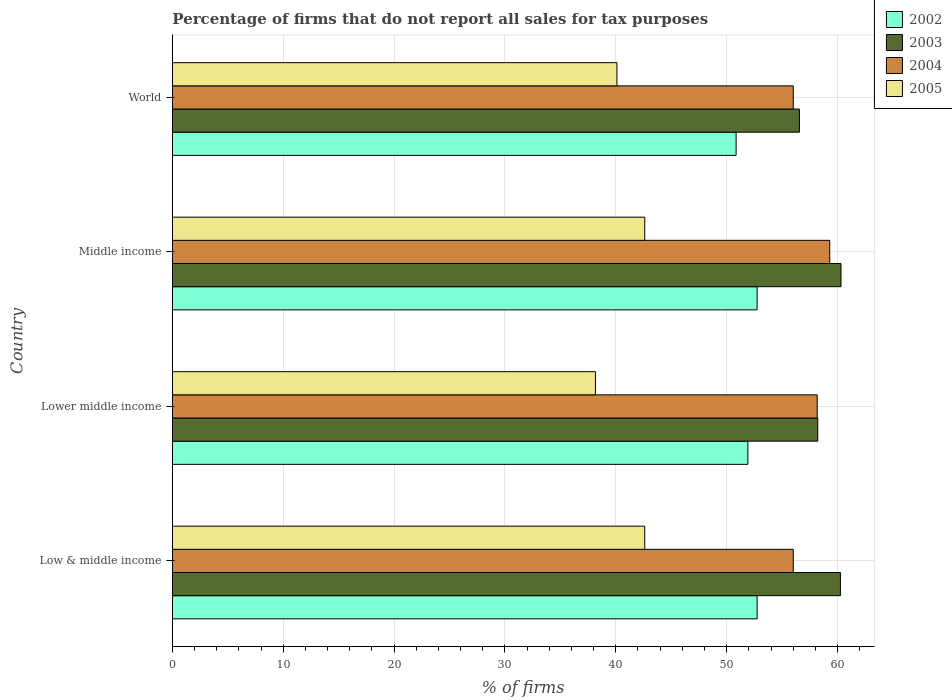Are the number of bars per tick equal to the number of legend labels?
Your answer should be compact. Yes. How many bars are there on the 3rd tick from the top?
Provide a succinct answer. 4. How many bars are there on the 1st tick from the bottom?
Your response must be concise. 4. What is the label of the 2nd group of bars from the top?
Ensure brevity in your answer.  Middle income. What is the percentage of firms that do not report all sales for tax purposes in 2002 in Low & middle income?
Provide a succinct answer. 52.75. Across all countries, what is the maximum percentage of firms that do not report all sales for tax purposes in 2003?
Provide a short and direct response. 60.31. Across all countries, what is the minimum percentage of firms that do not report all sales for tax purposes in 2005?
Offer a very short reply. 38.16. In which country was the percentage of firms that do not report all sales for tax purposes in 2003 maximum?
Make the answer very short. Middle income. What is the total percentage of firms that do not report all sales for tax purposes in 2004 in the graph?
Offer a terse response. 229.47. What is the difference between the percentage of firms that do not report all sales for tax purposes in 2003 in Lower middle income and that in World?
Keep it short and to the point. 1.66. What is the difference between the percentage of firms that do not report all sales for tax purposes in 2003 in Lower middle income and the percentage of firms that do not report all sales for tax purposes in 2004 in World?
Ensure brevity in your answer.  2.21. What is the average percentage of firms that do not report all sales for tax purposes in 2004 per country?
Give a very brief answer. 57.37. What is the difference between the percentage of firms that do not report all sales for tax purposes in 2005 and percentage of firms that do not report all sales for tax purposes in 2002 in Middle income?
Give a very brief answer. -10.13. In how many countries, is the percentage of firms that do not report all sales for tax purposes in 2005 greater than 2 %?
Offer a very short reply. 4. What is the ratio of the percentage of firms that do not report all sales for tax purposes in 2003 in Low & middle income to that in Middle income?
Offer a very short reply. 1. Is the percentage of firms that do not report all sales for tax purposes in 2005 in Low & middle income less than that in World?
Offer a very short reply. No. What is the difference between the highest and the lowest percentage of firms that do not report all sales for tax purposes in 2004?
Offer a very short reply. 3.29. What does the 1st bar from the top in Low & middle income represents?
Offer a very short reply. 2005. What is the difference between two consecutive major ticks on the X-axis?
Your answer should be very brief. 10. Does the graph contain any zero values?
Offer a very short reply. No. Does the graph contain grids?
Offer a terse response. Yes. Where does the legend appear in the graph?
Make the answer very short. Top right. How many legend labels are there?
Your response must be concise. 4. How are the legend labels stacked?
Provide a succinct answer. Vertical. What is the title of the graph?
Give a very brief answer. Percentage of firms that do not report all sales for tax purposes. What is the label or title of the X-axis?
Offer a very short reply. % of firms. What is the % of firms of 2002 in Low & middle income?
Offer a very short reply. 52.75. What is the % of firms in 2003 in Low & middle income?
Keep it short and to the point. 60.26. What is the % of firms of 2004 in Low & middle income?
Your response must be concise. 56.01. What is the % of firms of 2005 in Low & middle income?
Provide a short and direct response. 42.61. What is the % of firms in 2002 in Lower middle income?
Offer a very short reply. 51.91. What is the % of firms of 2003 in Lower middle income?
Your answer should be very brief. 58.22. What is the % of firms in 2004 in Lower middle income?
Ensure brevity in your answer.  58.16. What is the % of firms of 2005 in Lower middle income?
Provide a short and direct response. 38.16. What is the % of firms of 2002 in Middle income?
Provide a short and direct response. 52.75. What is the % of firms in 2003 in Middle income?
Your answer should be very brief. 60.31. What is the % of firms in 2004 in Middle income?
Offer a terse response. 59.3. What is the % of firms of 2005 in Middle income?
Provide a succinct answer. 42.61. What is the % of firms in 2002 in World?
Give a very brief answer. 50.85. What is the % of firms of 2003 in World?
Give a very brief answer. 56.56. What is the % of firms of 2004 in World?
Offer a very short reply. 56.01. What is the % of firms of 2005 in World?
Offer a very short reply. 40.1. Across all countries, what is the maximum % of firms of 2002?
Your answer should be very brief. 52.75. Across all countries, what is the maximum % of firms in 2003?
Your answer should be very brief. 60.31. Across all countries, what is the maximum % of firms of 2004?
Offer a terse response. 59.3. Across all countries, what is the maximum % of firms of 2005?
Give a very brief answer. 42.61. Across all countries, what is the minimum % of firms of 2002?
Provide a short and direct response. 50.85. Across all countries, what is the minimum % of firms in 2003?
Give a very brief answer. 56.56. Across all countries, what is the minimum % of firms in 2004?
Provide a short and direct response. 56.01. Across all countries, what is the minimum % of firms of 2005?
Your answer should be compact. 38.16. What is the total % of firms of 2002 in the graph?
Provide a succinct answer. 208.25. What is the total % of firms in 2003 in the graph?
Offer a very short reply. 235.35. What is the total % of firms in 2004 in the graph?
Keep it short and to the point. 229.47. What is the total % of firms of 2005 in the graph?
Keep it short and to the point. 163.48. What is the difference between the % of firms in 2002 in Low & middle income and that in Lower middle income?
Give a very brief answer. 0.84. What is the difference between the % of firms in 2003 in Low & middle income and that in Lower middle income?
Your response must be concise. 2.04. What is the difference between the % of firms in 2004 in Low & middle income and that in Lower middle income?
Offer a very short reply. -2.16. What is the difference between the % of firms in 2005 in Low & middle income and that in Lower middle income?
Offer a very short reply. 4.45. What is the difference between the % of firms in 2003 in Low & middle income and that in Middle income?
Your answer should be compact. -0.05. What is the difference between the % of firms in 2004 in Low & middle income and that in Middle income?
Your answer should be very brief. -3.29. What is the difference between the % of firms of 2005 in Low & middle income and that in Middle income?
Provide a short and direct response. 0. What is the difference between the % of firms in 2002 in Low & middle income and that in World?
Keep it short and to the point. 1.89. What is the difference between the % of firms of 2003 in Low & middle income and that in World?
Give a very brief answer. 3.7. What is the difference between the % of firms of 2005 in Low & middle income and that in World?
Give a very brief answer. 2.51. What is the difference between the % of firms in 2002 in Lower middle income and that in Middle income?
Your response must be concise. -0.84. What is the difference between the % of firms of 2003 in Lower middle income and that in Middle income?
Provide a short and direct response. -2.09. What is the difference between the % of firms in 2004 in Lower middle income and that in Middle income?
Keep it short and to the point. -1.13. What is the difference between the % of firms of 2005 in Lower middle income and that in Middle income?
Your answer should be very brief. -4.45. What is the difference between the % of firms in 2002 in Lower middle income and that in World?
Your response must be concise. 1.06. What is the difference between the % of firms of 2003 in Lower middle income and that in World?
Offer a very short reply. 1.66. What is the difference between the % of firms of 2004 in Lower middle income and that in World?
Give a very brief answer. 2.16. What is the difference between the % of firms of 2005 in Lower middle income and that in World?
Offer a very short reply. -1.94. What is the difference between the % of firms in 2002 in Middle income and that in World?
Ensure brevity in your answer.  1.89. What is the difference between the % of firms of 2003 in Middle income and that in World?
Ensure brevity in your answer.  3.75. What is the difference between the % of firms of 2004 in Middle income and that in World?
Your response must be concise. 3.29. What is the difference between the % of firms in 2005 in Middle income and that in World?
Make the answer very short. 2.51. What is the difference between the % of firms in 2002 in Low & middle income and the % of firms in 2003 in Lower middle income?
Offer a very short reply. -5.47. What is the difference between the % of firms of 2002 in Low & middle income and the % of firms of 2004 in Lower middle income?
Offer a very short reply. -5.42. What is the difference between the % of firms in 2002 in Low & middle income and the % of firms in 2005 in Lower middle income?
Make the answer very short. 14.58. What is the difference between the % of firms in 2003 in Low & middle income and the % of firms in 2004 in Lower middle income?
Provide a short and direct response. 2.1. What is the difference between the % of firms in 2003 in Low & middle income and the % of firms in 2005 in Lower middle income?
Ensure brevity in your answer.  22.1. What is the difference between the % of firms in 2004 in Low & middle income and the % of firms in 2005 in Lower middle income?
Make the answer very short. 17.84. What is the difference between the % of firms of 2002 in Low & middle income and the % of firms of 2003 in Middle income?
Give a very brief answer. -7.57. What is the difference between the % of firms in 2002 in Low & middle income and the % of firms in 2004 in Middle income?
Keep it short and to the point. -6.55. What is the difference between the % of firms of 2002 in Low & middle income and the % of firms of 2005 in Middle income?
Ensure brevity in your answer.  10.13. What is the difference between the % of firms in 2003 in Low & middle income and the % of firms in 2004 in Middle income?
Provide a short and direct response. 0.96. What is the difference between the % of firms of 2003 in Low & middle income and the % of firms of 2005 in Middle income?
Your response must be concise. 17.65. What is the difference between the % of firms of 2004 in Low & middle income and the % of firms of 2005 in Middle income?
Make the answer very short. 13.39. What is the difference between the % of firms in 2002 in Low & middle income and the % of firms in 2003 in World?
Make the answer very short. -3.81. What is the difference between the % of firms in 2002 in Low & middle income and the % of firms in 2004 in World?
Offer a very short reply. -3.26. What is the difference between the % of firms of 2002 in Low & middle income and the % of firms of 2005 in World?
Ensure brevity in your answer.  12.65. What is the difference between the % of firms of 2003 in Low & middle income and the % of firms of 2004 in World?
Provide a short and direct response. 4.25. What is the difference between the % of firms of 2003 in Low & middle income and the % of firms of 2005 in World?
Your response must be concise. 20.16. What is the difference between the % of firms in 2004 in Low & middle income and the % of firms in 2005 in World?
Provide a succinct answer. 15.91. What is the difference between the % of firms in 2002 in Lower middle income and the % of firms in 2003 in Middle income?
Give a very brief answer. -8.4. What is the difference between the % of firms in 2002 in Lower middle income and the % of firms in 2004 in Middle income?
Make the answer very short. -7.39. What is the difference between the % of firms of 2002 in Lower middle income and the % of firms of 2005 in Middle income?
Keep it short and to the point. 9.3. What is the difference between the % of firms in 2003 in Lower middle income and the % of firms in 2004 in Middle income?
Your answer should be compact. -1.08. What is the difference between the % of firms in 2003 in Lower middle income and the % of firms in 2005 in Middle income?
Your response must be concise. 15.61. What is the difference between the % of firms in 2004 in Lower middle income and the % of firms in 2005 in Middle income?
Ensure brevity in your answer.  15.55. What is the difference between the % of firms of 2002 in Lower middle income and the % of firms of 2003 in World?
Keep it short and to the point. -4.65. What is the difference between the % of firms in 2002 in Lower middle income and the % of firms in 2004 in World?
Make the answer very short. -4.1. What is the difference between the % of firms in 2002 in Lower middle income and the % of firms in 2005 in World?
Give a very brief answer. 11.81. What is the difference between the % of firms of 2003 in Lower middle income and the % of firms of 2004 in World?
Offer a terse response. 2.21. What is the difference between the % of firms of 2003 in Lower middle income and the % of firms of 2005 in World?
Offer a terse response. 18.12. What is the difference between the % of firms in 2004 in Lower middle income and the % of firms in 2005 in World?
Your response must be concise. 18.07. What is the difference between the % of firms of 2002 in Middle income and the % of firms of 2003 in World?
Provide a short and direct response. -3.81. What is the difference between the % of firms in 2002 in Middle income and the % of firms in 2004 in World?
Your answer should be compact. -3.26. What is the difference between the % of firms in 2002 in Middle income and the % of firms in 2005 in World?
Give a very brief answer. 12.65. What is the difference between the % of firms of 2003 in Middle income and the % of firms of 2004 in World?
Offer a terse response. 4.31. What is the difference between the % of firms of 2003 in Middle income and the % of firms of 2005 in World?
Provide a succinct answer. 20.21. What is the difference between the % of firms of 2004 in Middle income and the % of firms of 2005 in World?
Offer a terse response. 19.2. What is the average % of firms of 2002 per country?
Give a very brief answer. 52.06. What is the average % of firms in 2003 per country?
Make the answer very short. 58.84. What is the average % of firms in 2004 per country?
Your answer should be compact. 57.37. What is the average % of firms of 2005 per country?
Ensure brevity in your answer.  40.87. What is the difference between the % of firms in 2002 and % of firms in 2003 in Low & middle income?
Your answer should be very brief. -7.51. What is the difference between the % of firms of 2002 and % of firms of 2004 in Low & middle income?
Your answer should be very brief. -3.26. What is the difference between the % of firms of 2002 and % of firms of 2005 in Low & middle income?
Provide a succinct answer. 10.13. What is the difference between the % of firms in 2003 and % of firms in 2004 in Low & middle income?
Ensure brevity in your answer.  4.25. What is the difference between the % of firms in 2003 and % of firms in 2005 in Low & middle income?
Your answer should be compact. 17.65. What is the difference between the % of firms in 2004 and % of firms in 2005 in Low & middle income?
Make the answer very short. 13.39. What is the difference between the % of firms of 2002 and % of firms of 2003 in Lower middle income?
Offer a terse response. -6.31. What is the difference between the % of firms of 2002 and % of firms of 2004 in Lower middle income?
Your answer should be compact. -6.26. What is the difference between the % of firms in 2002 and % of firms in 2005 in Lower middle income?
Your response must be concise. 13.75. What is the difference between the % of firms in 2003 and % of firms in 2004 in Lower middle income?
Your answer should be very brief. 0.05. What is the difference between the % of firms in 2003 and % of firms in 2005 in Lower middle income?
Offer a very short reply. 20.06. What is the difference between the % of firms in 2004 and % of firms in 2005 in Lower middle income?
Provide a short and direct response. 20. What is the difference between the % of firms in 2002 and % of firms in 2003 in Middle income?
Make the answer very short. -7.57. What is the difference between the % of firms of 2002 and % of firms of 2004 in Middle income?
Your answer should be compact. -6.55. What is the difference between the % of firms in 2002 and % of firms in 2005 in Middle income?
Provide a short and direct response. 10.13. What is the difference between the % of firms of 2003 and % of firms of 2004 in Middle income?
Make the answer very short. 1.02. What is the difference between the % of firms in 2003 and % of firms in 2005 in Middle income?
Give a very brief answer. 17.7. What is the difference between the % of firms in 2004 and % of firms in 2005 in Middle income?
Give a very brief answer. 16.69. What is the difference between the % of firms in 2002 and % of firms in 2003 in World?
Provide a short and direct response. -5.71. What is the difference between the % of firms of 2002 and % of firms of 2004 in World?
Provide a short and direct response. -5.15. What is the difference between the % of firms of 2002 and % of firms of 2005 in World?
Provide a succinct answer. 10.75. What is the difference between the % of firms in 2003 and % of firms in 2004 in World?
Provide a succinct answer. 0.56. What is the difference between the % of firms in 2003 and % of firms in 2005 in World?
Provide a short and direct response. 16.46. What is the difference between the % of firms of 2004 and % of firms of 2005 in World?
Offer a terse response. 15.91. What is the ratio of the % of firms of 2002 in Low & middle income to that in Lower middle income?
Your answer should be very brief. 1.02. What is the ratio of the % of firms in 2003 in Low & middle income to that in Lower middle income?
Provide a succinct answer. 1.04. What is the ratio of the % of firms of 2004 in Low & middle income to that in Lower middle income?
Make the answer very short. 0.96. What is the ratio of the % of firms of 2005 in Low & middle income to that in Lower middle income?
Provide a succinct answer. 1.12. What is the ratio of the % of firms of 2003 in Low & middle income to that in Middle income?
Your response must be concise. 1. What is the ratio of the % of firms of 2004 in Low & middle income to that in Middle income?
Your answer should be compact. 0.94. What is the ratio of the % of firms in 2005 in Low & middle income to that in Middle income?
Give a very brief answer. 1. What is the ratio of the % of firms in 2002 in Low & middle income to that in World?
Provide a short and direct response. 1.04. What is the ratio of the % of firms in 2003 in Low & middle income to that in World?
Your answer should be very brief. 1.07. What is the ratio of the % of firms in 2005 in Low & middle income to that in World?
Your answer should be compact. 1.06. What is the ratio of the % of firms in 2002 in Lower middle income to that in Middle income?
Provide a short and direct response. 0.98. What is the ratio of the % of firms of 2003 in Lower middle income to that in Middle income?
Make the answer very short. 0.97. What is the ratio of the % of firms in 2004 in Lower middle income to that in Middle income?
Your response must be concise. 0.98. What is the ratio of the % of firms of 2005 in Lower middle income to that in Middle income?
Give a very brief answer. 0.9. What is the ratio of the % of firms of 2002 in Lower middle income to that in World?
Offer a terse response. 1.02. What is the ratio of the % of firms of 2003 in Lower middle income to that in World?
Ensure brevity in your answer.  1.03. What is the ratio of the % of firms in 2004 in Lower middle income to that in World?
Your answer should be very brief. 1.04. What is the ratio of the % of firms in 2005 in Lower middle income to that in World?
Offer a terse response. 0.95. What is the ratio of the % of firms of 2002 in Middle income to that in World?
Provide a succinct answer. 1.04. What is the ratio of the % of firms in 2003 in Middle income to that in World?
Keep it short and to the point. 1.07. What is the ratio of the % of firms in 2004 in Middle income to that in World?
Your response must be concise. 1.06. What is the ratio of the % of firms in 2005 in Middle income to that in World?
Offer a terse response. 1.06. What is the difference between the highest and the second highest % of firms of 2003?
Offer a terse response. 0.05. What is the difference between the highest and the second highest % of firms of 2004?
Your answer should be very brief. 1.13. What is the difference between the highest and the lowest % of firms in 2002?
Keep it short and to the point. 1.89. What is the difference between the highest and the lowest % of firms of 2003?
Offer a terse response. 3.75. What is the difference between the highest and the lowest % of firms in 2004?
Provide a succinct answer. 3.29. What is the difference between the highest and the lowest % of firms in 2005?
Offer a very short reply. 4.45. 